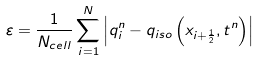Convert formula to latex. <formula><loc_0><loc_0><loc_500><loc_500>\varepsilon = \frac { 1 } { N _ { c e l l } } \sum _ { i = 1 } ^ { N } \left | q _ { i } ^ { n } - q _ { i s o } \left ( x _ { i + \frac { 1 } { 2 } } , t ^ { n } \right ) \right |</formula> 